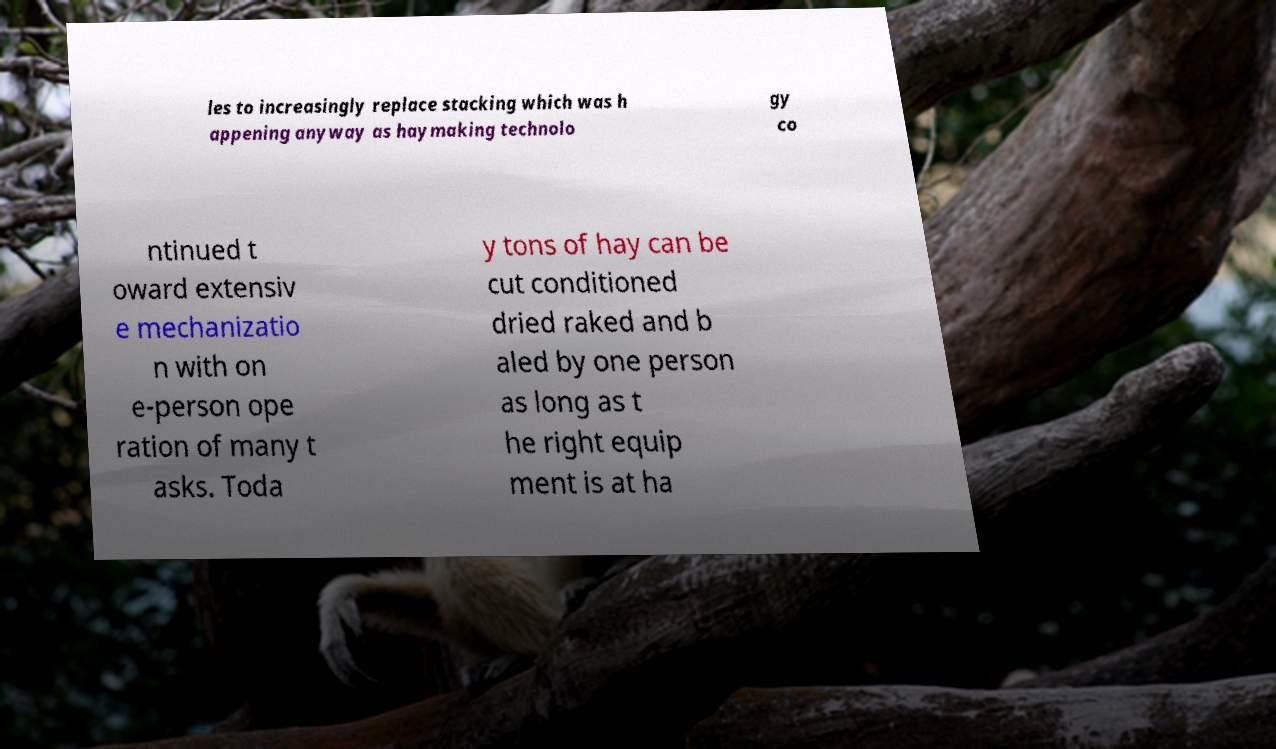Can you accurately transcribe the text from the provided image for me? les to increasingly replace stacking which was h appening anyway as haymaking technolo gy co ntinued t oward extensiv e mechanizatio n with on e-person ope ration of many t asks. Toda y tons of hay can be cut conditioned dried raked and b aled by one person as long as t he right equip ment is at ha 